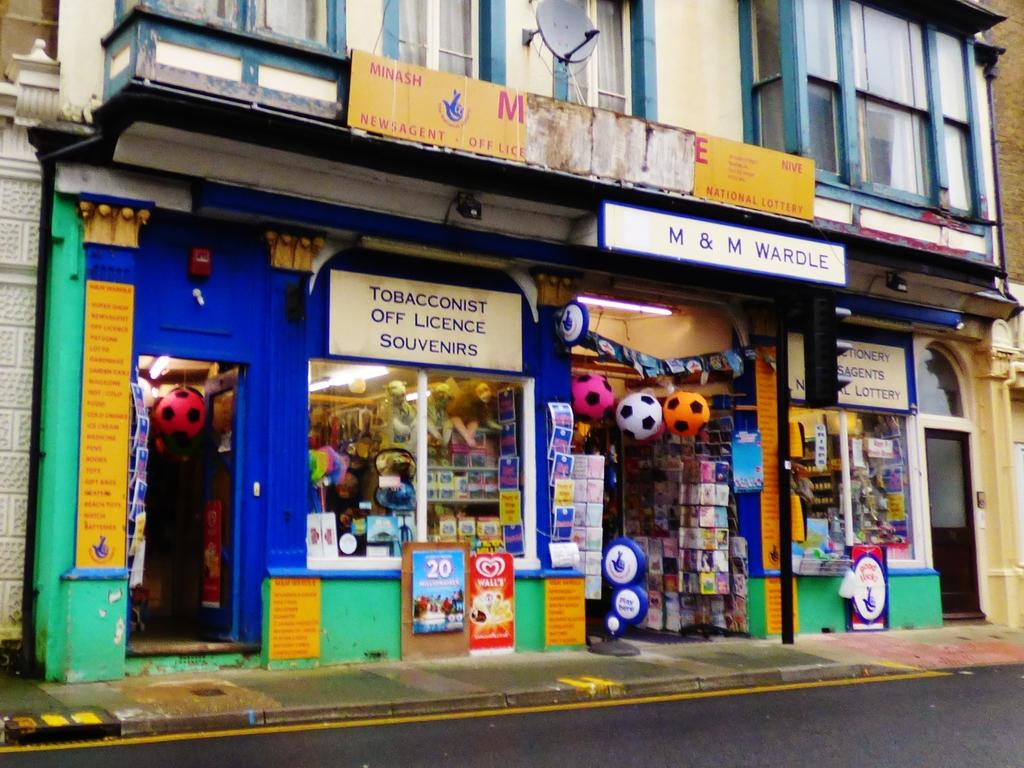<image>
Render a clear and concise summary of the photo. Several advertisements and signs adorn the M&M Wardle store. 